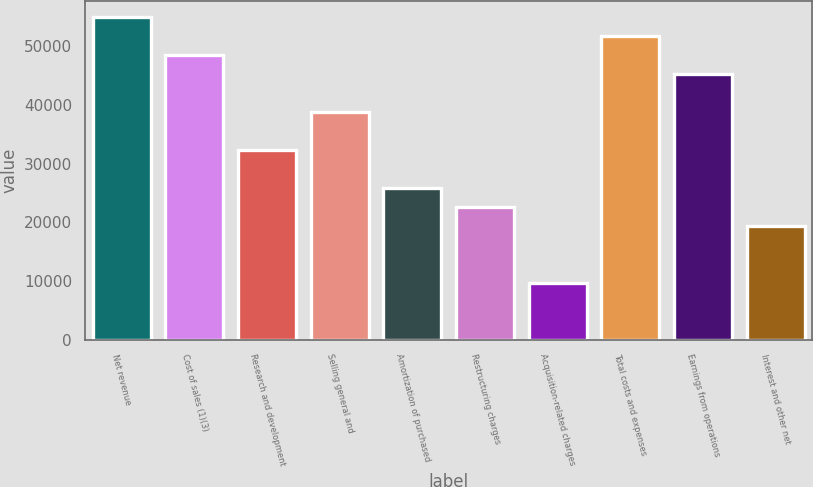Convert chart to OTSL. <chart><loc_0><loc_0><loc_500><loc_500><bar_chart><fcel>Net revenue<fcel>Cost of sales (1)(3)<fcel>Research and development<fcel>Selling general and<fcel>Amortization of purchased<fcel>Restructuring charges<fcel>Acquisition-related charges<fcel>Total costs and expenses<fcel>Earnings from operations<fcel>Interest and other net<nl><fcel>54913.3<fcel>48452.9<fcel>32302<fcel>38762.4<fcel>25841.6<fcel>22611.4<fcel>9690.65<fcel>51683.1<fcel>45222.7<fcel>19381.2<nl></chart> 